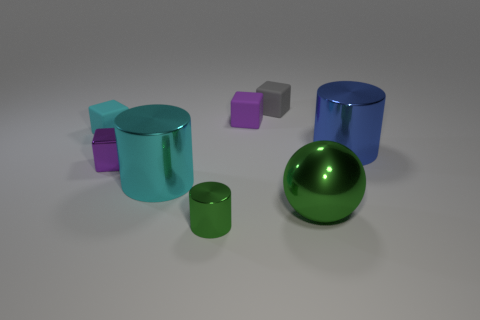What is the color of the matte block that is to the right of the small green metal thing and in front of the tiny gray thing?
Provide a short and direct response. Purple. There is a thing that is right of the green metal object right of the small purple object that is behind the big blue cylinder; what is its material?
Offer a very short reply. Metal. What is the cyan cylinder made of?
Offer a terse response. Metal. What is the size of the blue thing that is the same shape as the cyan metal object?
Offer a very short reply. Large. Do the small metal cube and the big ball have the same color?
Offer a very short reply. No. What number of other things are the same material as the big green ball?
Offer a very short reply. 4. Are there an equal number of big blue objects in front of the small shiny block and tiny shiny things?
Provide a short and direct response. No. There is a blue metal object on the right side of the gray rubber thing; is its size the same as the cyan metal thing?
Give a very brief answer. Yes. How many blue shiny cylinders are right of the small cyan rubber thing?
Keep it short and to the point. 1. There is a small block that is both behind the cyan matte thing and on the left side of the tiny gray object; what material is it?
Your answer should be very brief. Rubber. 